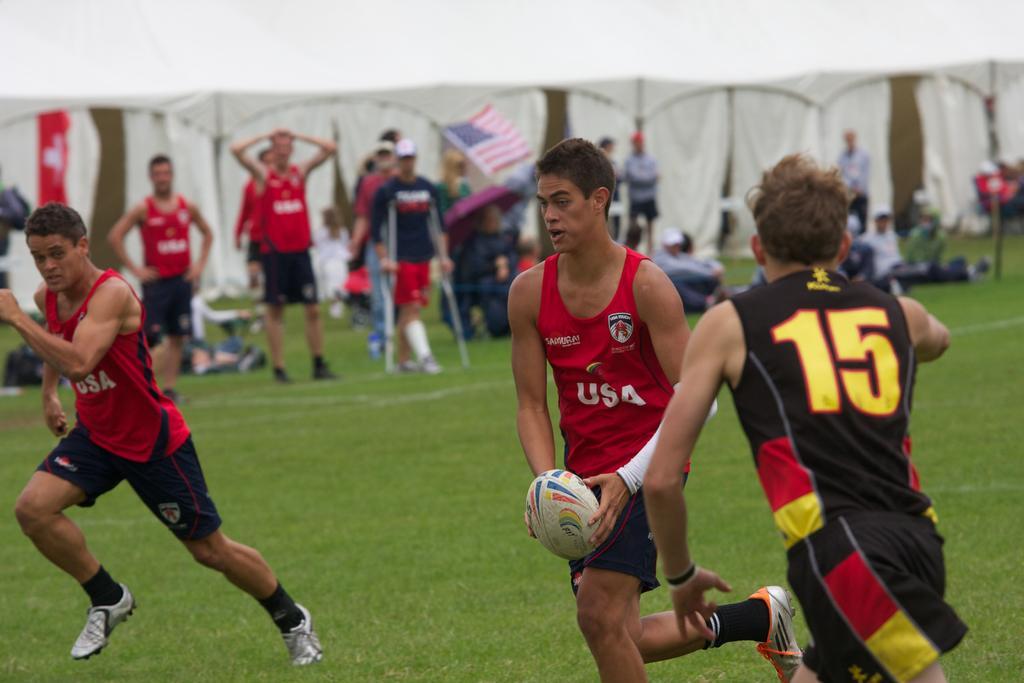Describe this image in one or two sentences. In this image there are people playing game on a ground, in the background there are people standing and it is blurred. 